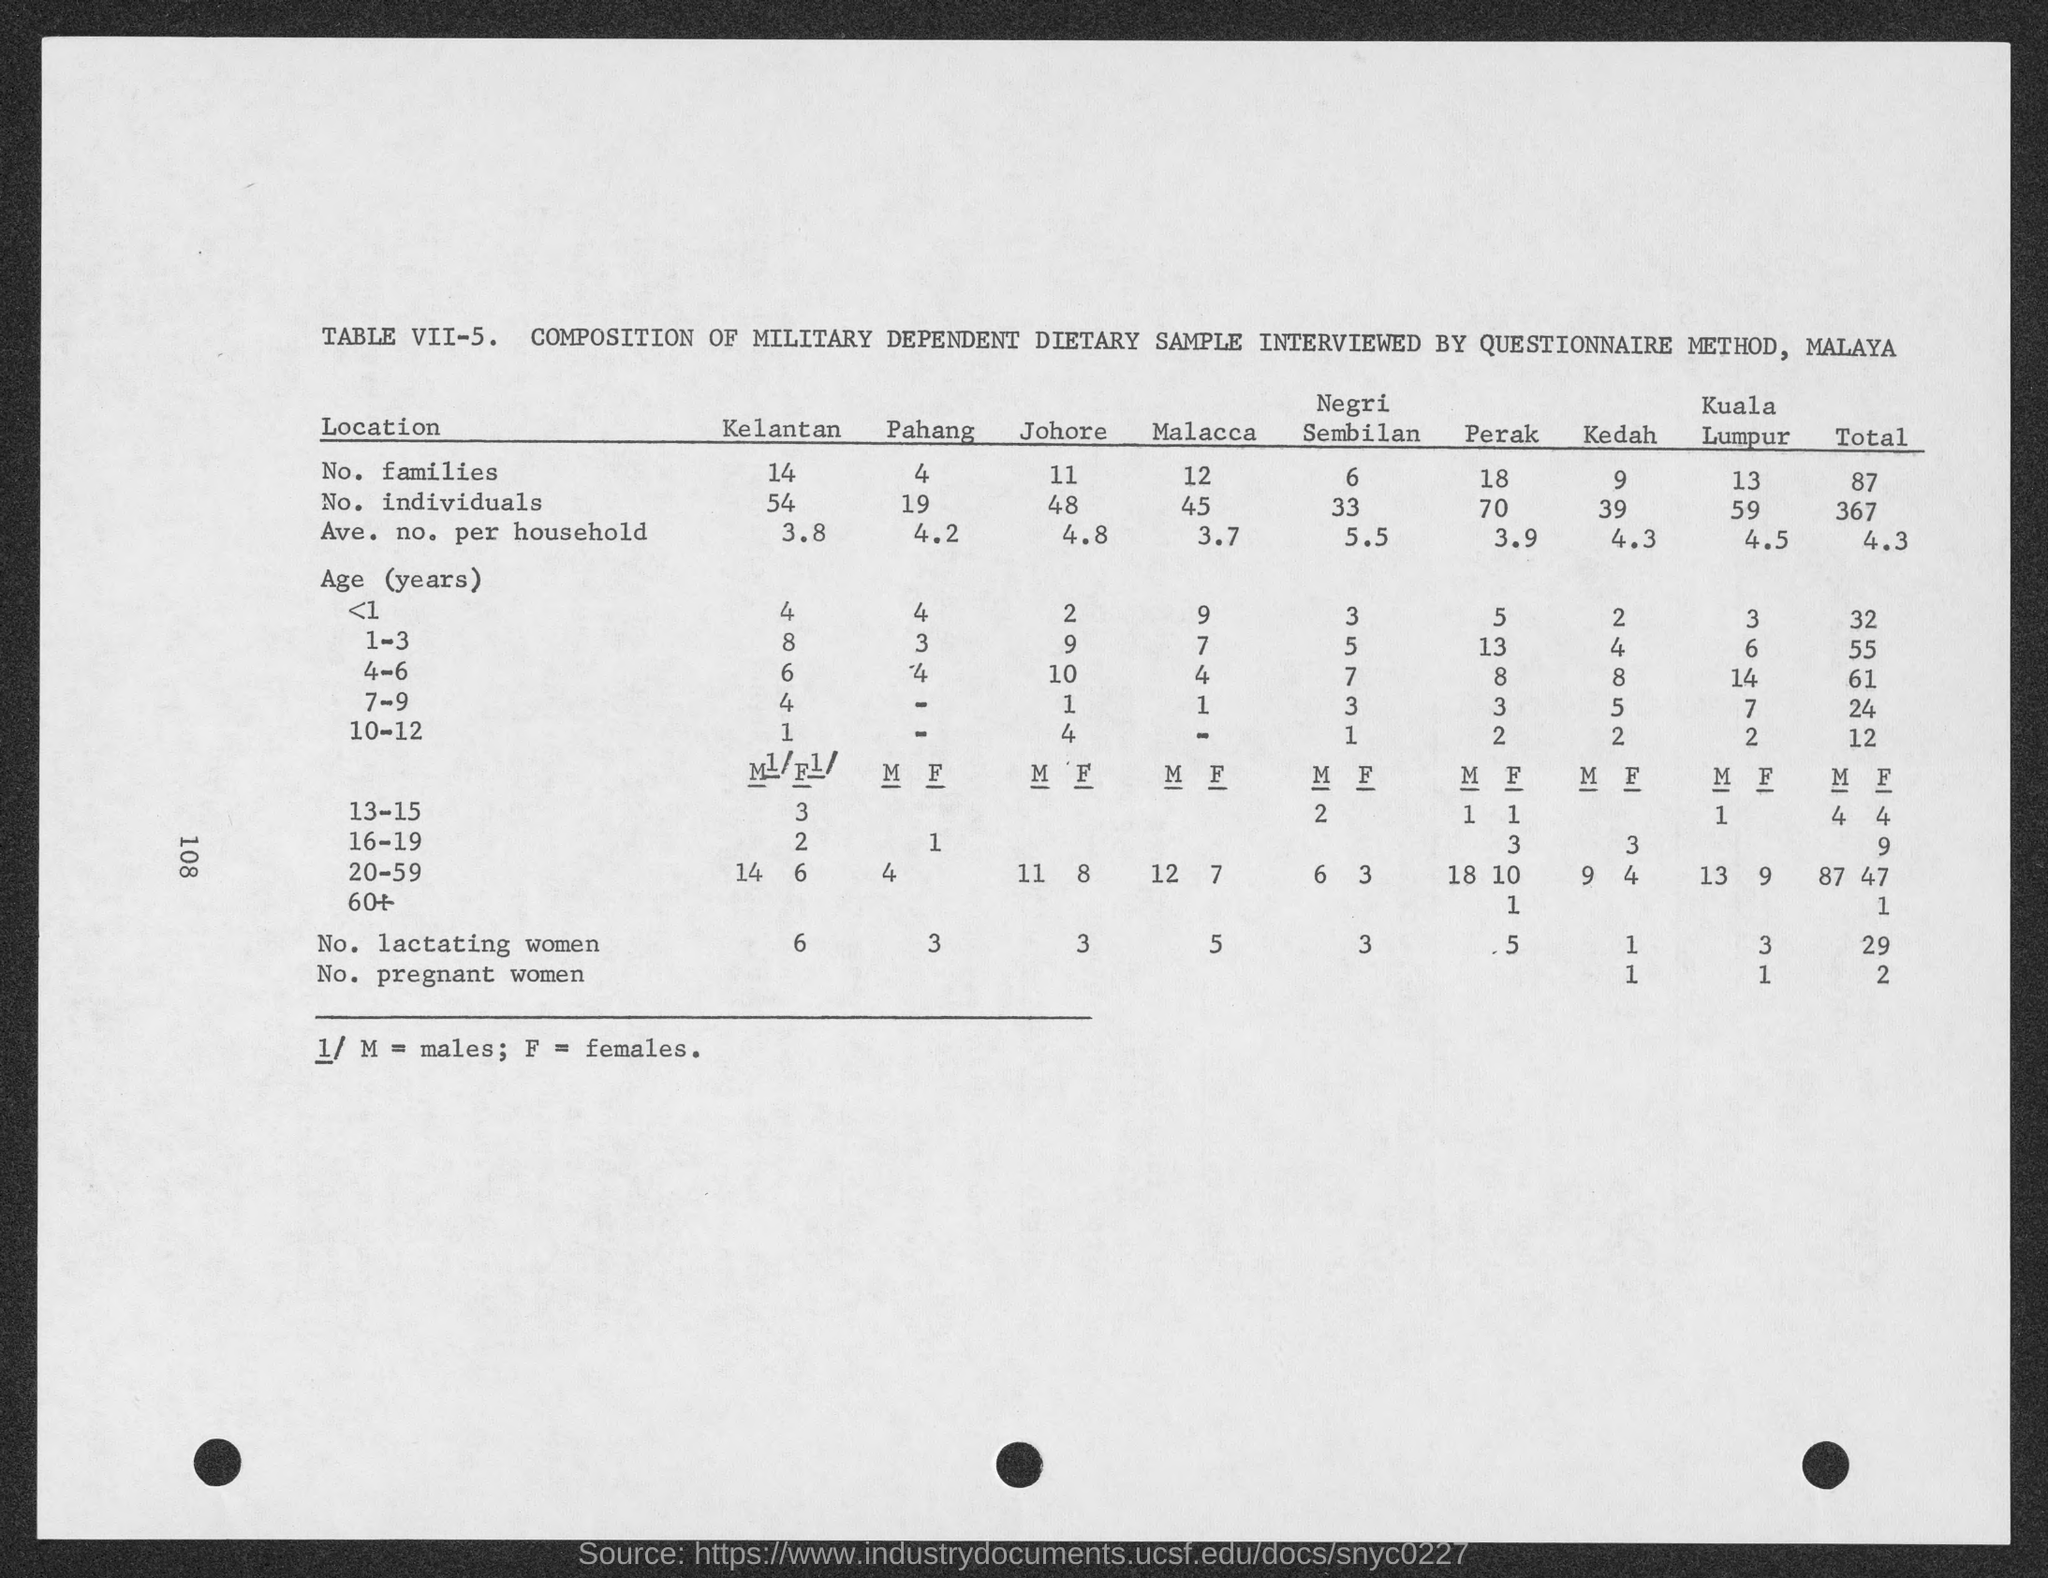What is the no. of families in kelantan ?
Your answer should be compact. 14. What is the no. of families in pahang?
Provide a succinct answer. 4. What is the no. of families in johore?
Your response must be concise. 11. What is the no. of families in malacca?
Your answer should be very brief. 12. What is the no. of families in negri sembilan ?
Provide a short and direct response. 6. What is the no. of families in perak?
Provide a succinct answer. 18. What is the no. of families in kedah?
Make the answer very short. 9. What is the no. of families in kuala lumpur ?
Provide a short and direct response. 13. What is the no. of individuals in kelantan?
Offer a very short reply. 54. What is the no. of individuals in pahang?
Keep it short and to the point. 19. 